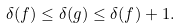<formula> <loc_0><loc_0><loc_500><loc_500>\delta ( f ) \leq \delta ( g ) \leq \delta ( f ) + 1 .</formula> 